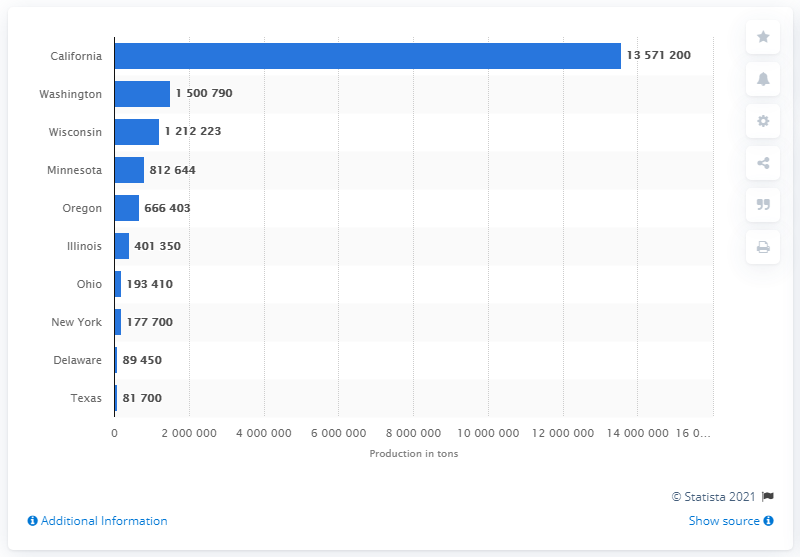Point out several critical features in this image. In 2016, a total of 81,700 tons of principal vegetables for processing were produced in Texas. The sum of values below 100,000 is 171,150. California has the highest processing. 